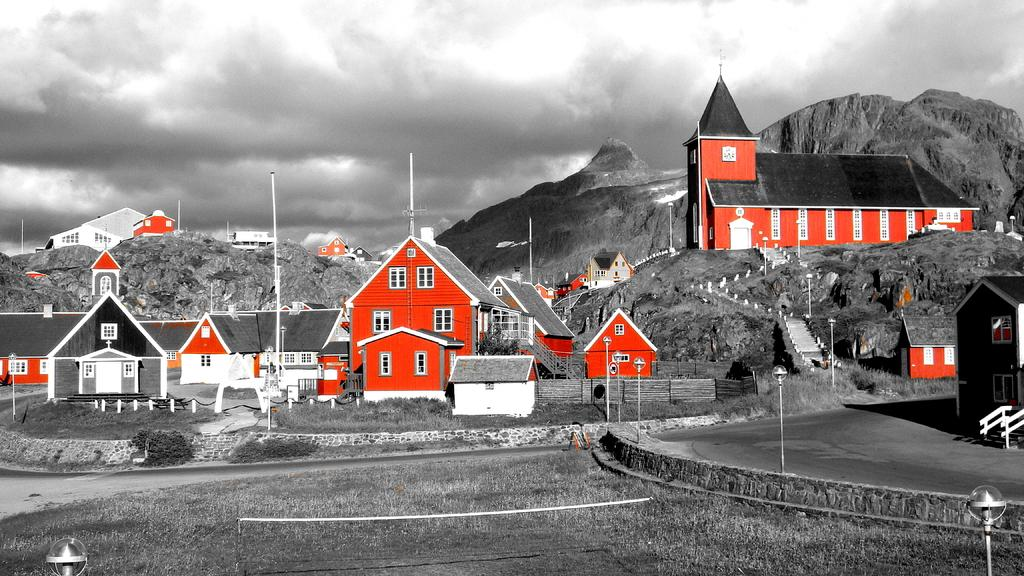What type of vegetation is present in the image? There is grass in the image. What structure can be seen in the image? There is a net and poles in the image. What might be used for illumination in the image? There are lights in the image. What type of pathway is visible in the image? There is a road in the image. What type of residential structures can be seen in the image? There are houses in the image. What type of natural features are present in the image? There are plants and hills in the image. What is visible in the background of the image? The sky is visible in the background of the image, with clouds present. What type of statement is being made by the grass in the image? The grass does not make any statements in the image; it is a natural feature. Were there any slaves present in the image? There is no mention of any slaves in the image, and it is not appropriate to make assumptions about the image based on unrelated topics. 